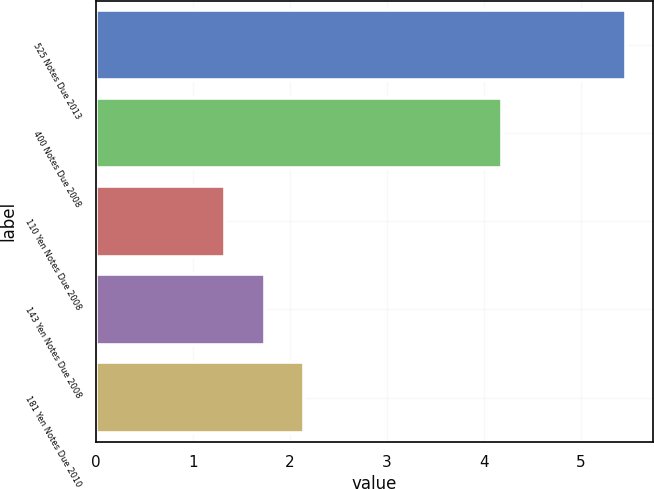Convert chart to OTSL. <chart><loc_0><loc_0><loc_500><loc_500><bar_chart><fcel>525 Notes Due 2013<fcel>400 Notes Due 2008<fcel>110 Yen Notes Due 2008<fcel>143 Yen Notes Due 2008<fcel>181 Yen Notes Due 2010<nl><fcel>5.47<fcel>4.19<fcel>1.33<fcel>1.74<fcel>2.15<nl></chart> 